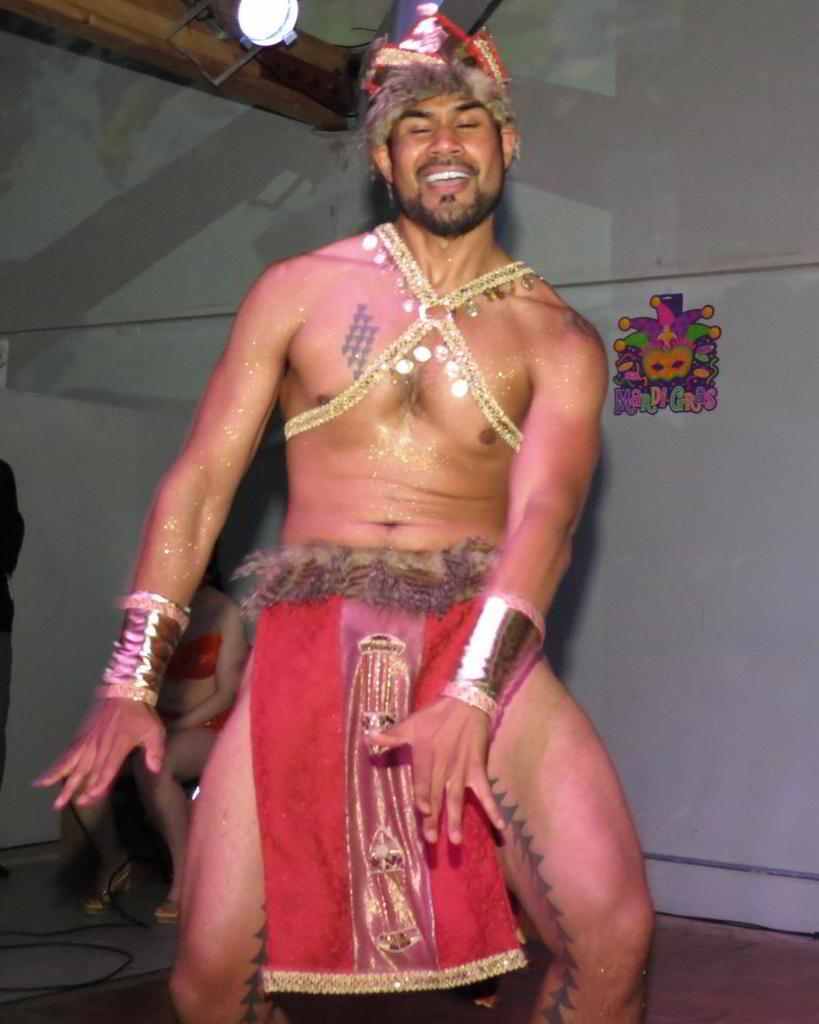What is the person in the image doing? There is a person dancing in the image. What is the other person in the image doing? The other person is sitting on a chair in the image. What can be seen in the background of the image? There is a tent in the background of the image. What is providing illumination in the image? There is a light in the image. What type of brick is being used to build the tent in the image? There is no tent being built in the image; there is a tent already present in the background. Additionally, there is no mention of bricks in the provided facts. 